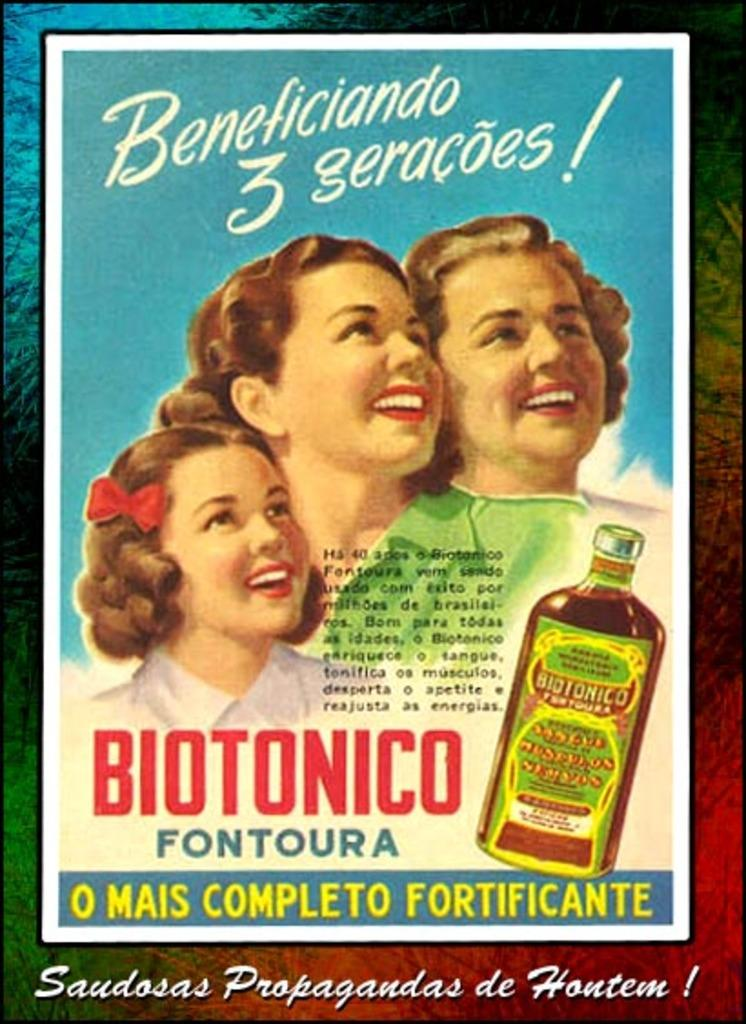<image>
Present a compact description of the photo's key features. A vintage signs that tells people there product is beneficiando 3 geracoes. 